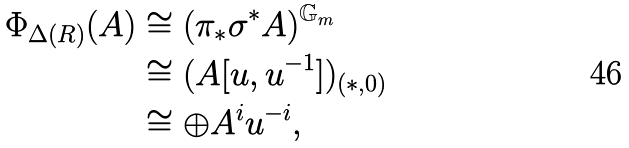Convert formula to latex. <formula><loc_0><loc_0><loc_500><loc_500>\Phi _ { \Delta ( R ) } ( A ) & \cong ( \pi _ { * } \sigma ^ { * } A ) ^ { \mathbb { G } _ { m } } \\ & \cong ( A [ u , u ^ { - 1 } ] ) _ { ( * , 0 ) } \\ & \cong \oplus A ^ { i } u ^ { - i } ,</formula> 